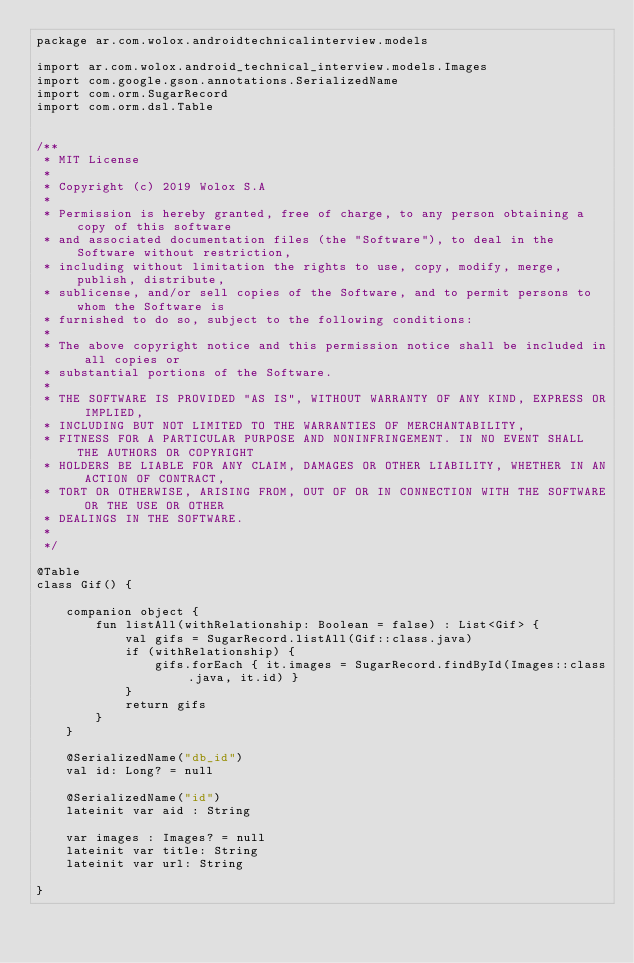Convert code to text. <code><loc_0><loc_0><loc_500><loc_500><_Kotlin_>package ar.com.wolox.androidtechnicalinterview.models

import ar.com.wolox.android_technical_interview.models.Images
import com.google.gson.annotations.SerializedName
import com.orm.SugarRecord
import com.orm.dsl.Table


/**
 * MIT License
 *
 * Copyright (c) 2019 Wolox S.A
 *
 * Permission is hereby granted, free of charge, to any person obtaining a copy of this software
 * and associated documentation files (the "Software"), to deal in the Software without restriction,
 * including without limitation the rights to use, copy, modify, merge, publish, distribute,
 * sublicense, and/or sell copies of the Software, and to permit persons to whom the Software is
 * furnished to do so, subject to the following conditions:
 *
 * The above copyright notice and this permission notice shall be included in all copies or
 * substantial portions of the Software.
 *
 * THE SOFTWARE IS PROVIDED "AS IS", WITHOUT WARRANTY OF ANY KIND, EXPRESS OR IMPLIED,
 * INCLUDING BUT NOT LIMITED TO THE WARRANTIES OF MERCHANTABILITY,
 * FITNESS FOR A PARTICULAR PURPOSE AND NONINFRINGEMENT. IN NO EVENT SHALL THE AUTHORS OR COPYRIGHT
 * HOLDERS BE LIABLE FOR ANY CLAIM, DAMAGES OR OTHER LIABILITY, WHETHER IN AN ACTION OF CONTRACT,
 * TORT OR OTHERWISE, ARISING FROM, OUT OF OR IN CONNECTION WITH THE SOFTWARE OR THE USE OR OTHER
 * DEALINGS IN THE SOFTWARE.
 *
 */

@Table
class Gif() {

    companion object {
        fun listAll(withRelationship: Boolean = false) : List<Gif> {
            val gifs = SugarRecord.listAll(Gif::class.java)
            if (withRelationship) {
                gifs.forEach { it.images = SugarRecord.findById(Images::class.java, it.id) }
            }
            return gifs
        }
    }

    @SerializedName("db_id")
    val id: Long? = null

    @SerializedName("id")
    lateinit var aid : String

    var images : Images? = null
    lateinit var title: String
    lateinit var url: String

}</code> 